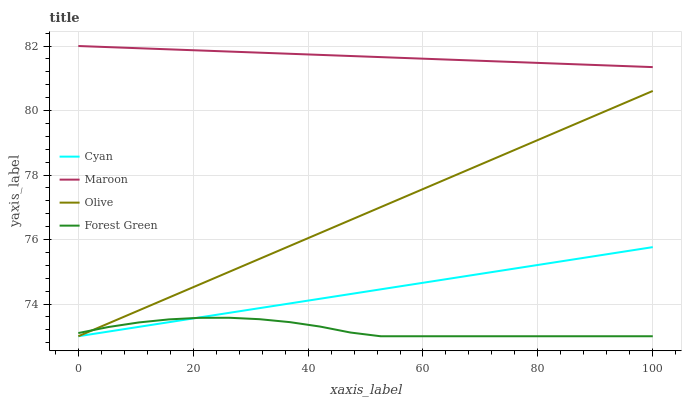Does Forest Green have the minimum area under the curve?
Answer yes or no. Yes. Does Maroon have the maximum area under the curve?
Answer yes or no. Yes. Does Cyan have the minimum area under the curve?
Answer yes or no. No. Does Cyan have the maximum area under the curve?
Answer yes or no. No. Is Olive the smoothest?
Answer yes or no. Yes. Is Forest Green the roughest?
Answer yes or no. Yes. Is Cyan the smoothest?
Answer yes or no. No. Is Cyan the roughest?
Answer yes or no. No. Does Maroon have the lowest value?
Answer yes or no. No. Does Cyan have the highest value?
Answer yes or no. No. Is Cyan less than Maroon?
Answer yes or no. Yes. Is Maroon greater than Cyan?
Answer yes or no. Yes. Does Cyan intersect Maroon?
Answer yes or no. No. 